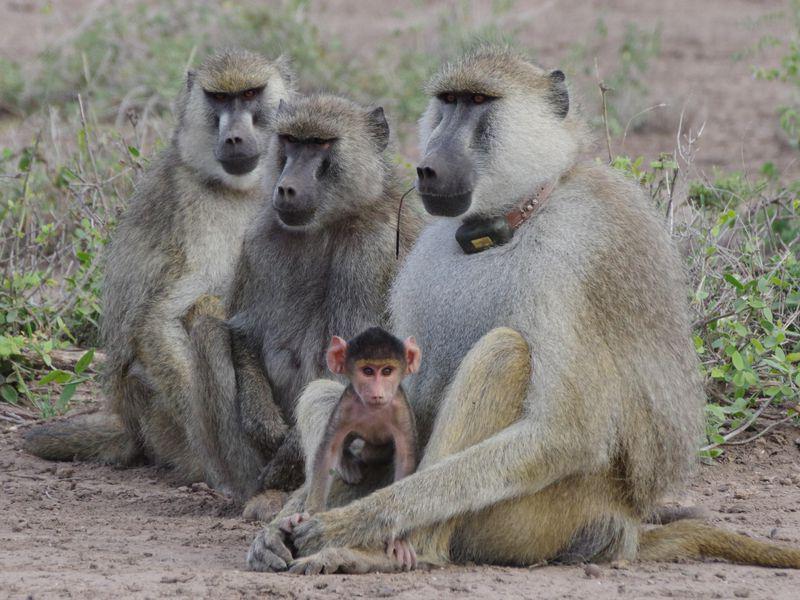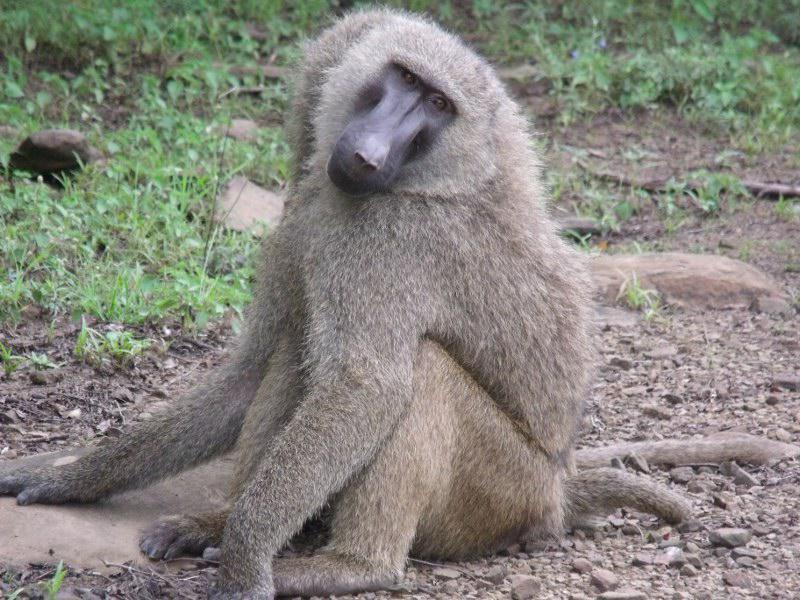The first image is the image on the left, the second image is the image on the right. For the images displayed, is the sentence "One image features a baby baboon next to an adult baboon" factually correct? Answer yes or no. Yes. The first image is the image on the left, the second image is the image on the right. Evaluate the accuracy of this statement regarding the images: "There are exactly three monkeys". Is it true? Answer yes or no. No. 